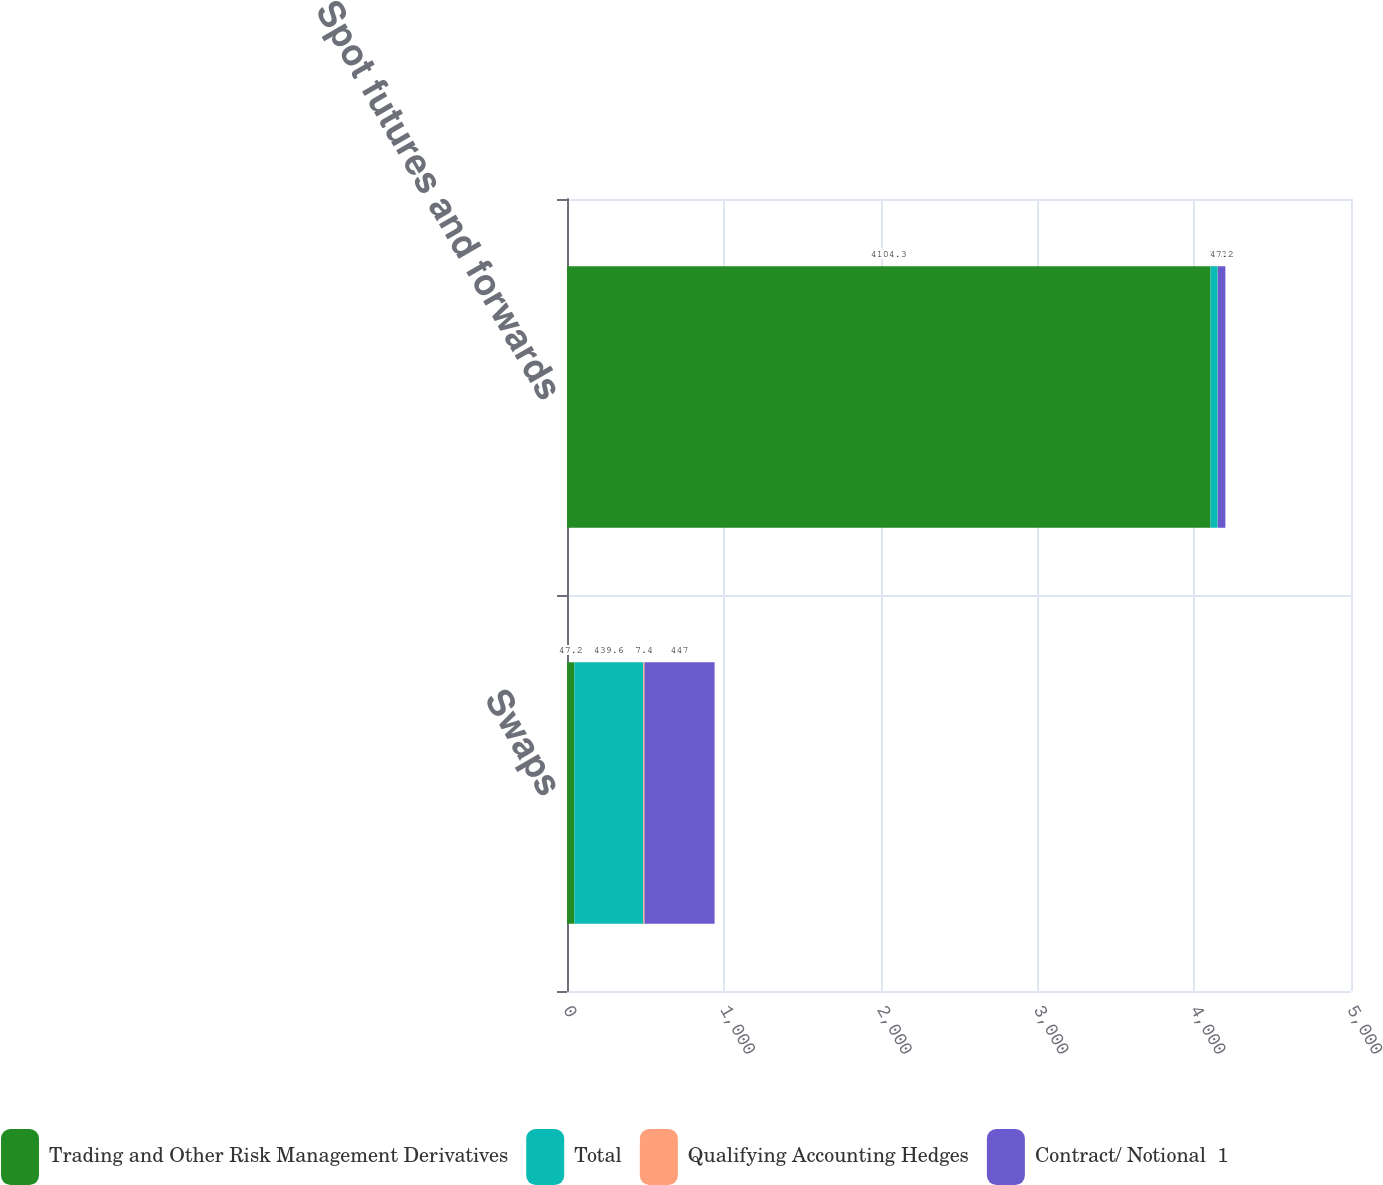Convert chart to OTSL. <chart><loc_0><loc_0><loc_500><loc_500><stacked_bar_chart><ecel><fcel>Swaps<fcel>Spot futures and forwards<nl><fcel>Trading and Other Risk Management Derivatives<fcel>47.2<fcel>4104.3<nl><fcel>Total<fcel>439.6<fcel>46<nl><fcel>Qualifying Accounting Hedges<fcel>7.4<fcel>1.2<nl><fcel>Contract/ Notional  1<fcel>447<fcel>47.2<nl></chart> 